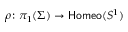Convert formula to latex. <formula><loc_0><loc_0><loc_500><loc_500>\rho \colon \pi _ { 1 } ( \Sigma ) \rightarrow { H o m e o } ( S ^ { 1 } )</formula> 